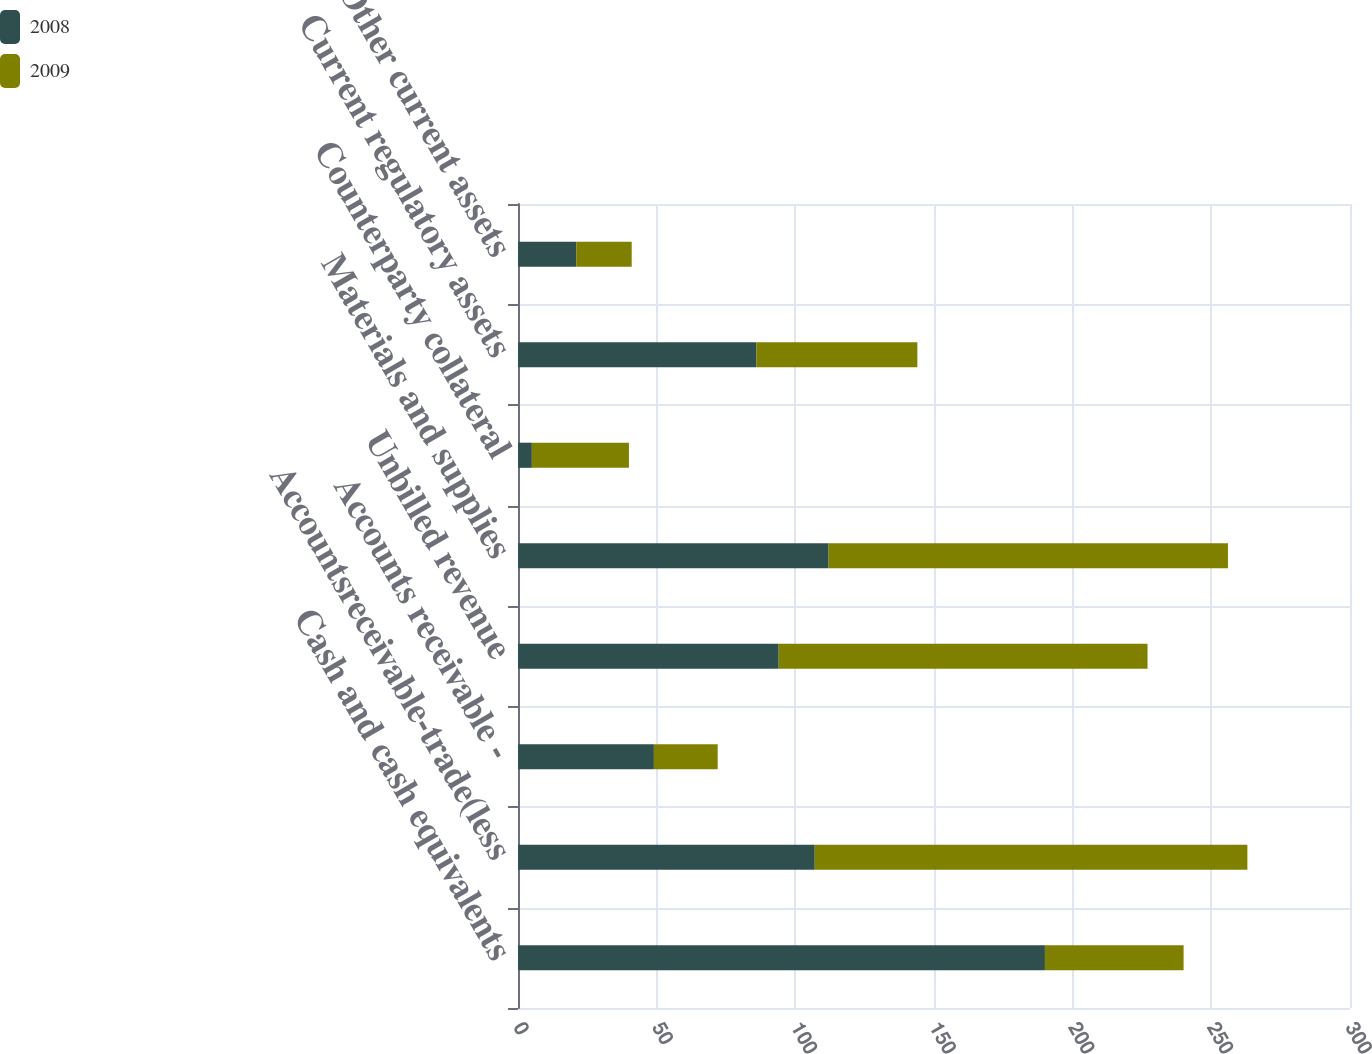Convert chart. <chart><loc_0><loc_0><loc_500><loc_500><stacked_bar_chart><ecel><fcel>Cash and cash equivalents<fcel>Accountsreceivable-trade(less<fcel>Accounts receivable -<fcel>Unbilled revenue<fcel>Materials and supplies<fcel>Counterparty collateral<fcel>Current regulatory assets<fcel>Other current assets<nl><fcel>2008<fcel>190<fcel>107<fcel>49<fcel>94<fcel>112<fcel>5<fcel>86<fcel>21<nl><fcel>2009<fcel>50<fcel>156<fcel>23<fcel>133<fcel>144<fcel>35<fcel>58<fcel>20<nl></chart> 